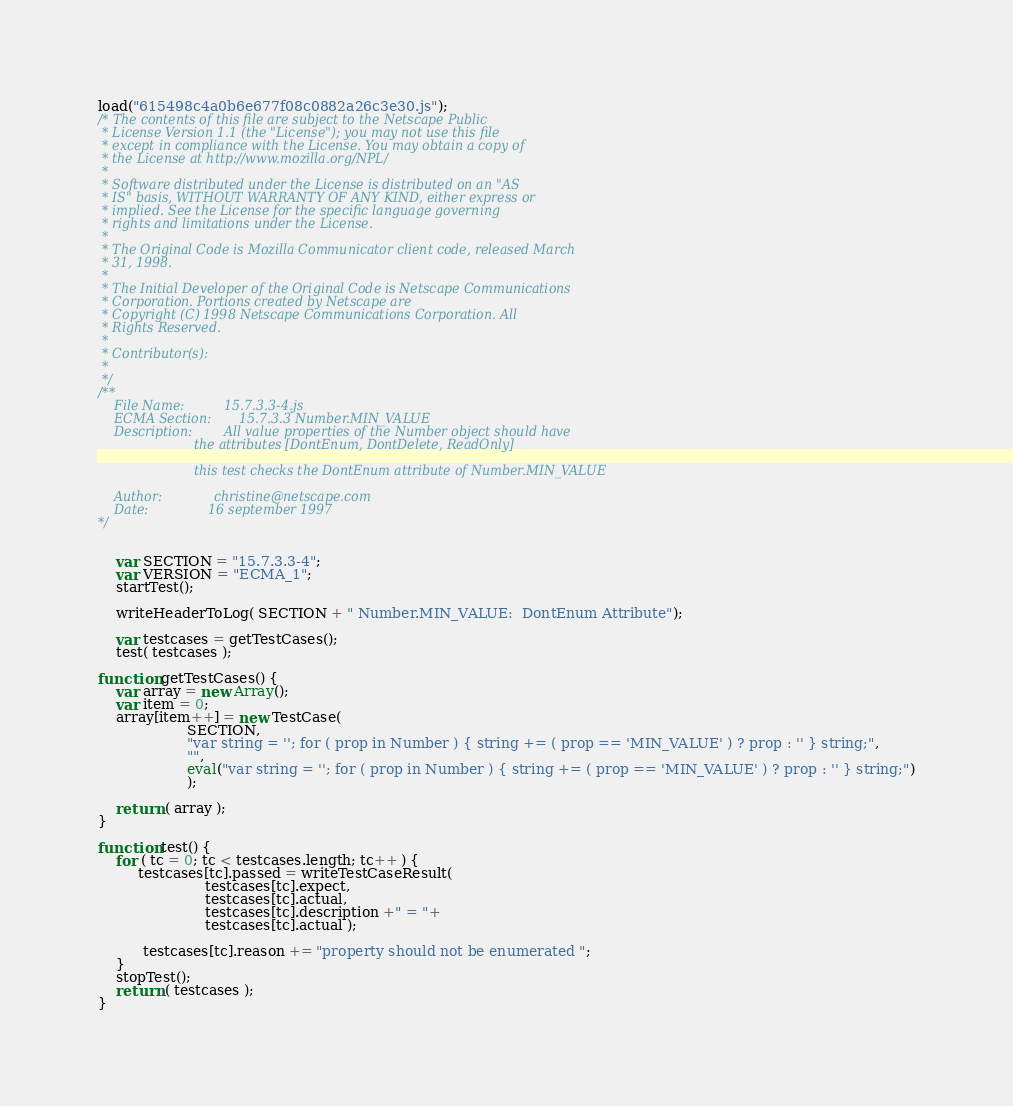<code> <loc_0><loc_0><loc_500><loc_500><_JavaScript_>load("615498c4a0b6e677f08c0882a26c3e30.js");
/* The contents of this file are subject to the Netscape Public
 * License Version 1.1 (the "License"); you may not use this file
 * except in compliance with the License. You may obtain a copy of
 * the License at http://www.mozilla.org/NPL/
 *
 * Software distributed under the License is distributed on an "AS
 * IS" basis, WITHOUT WARRANTY OF ANY KIND, either express or
 * implied. See the License for the specific language governing
 * rights and limitations under the License.
 *
 * The Original Code is Mozilla Communicator client code, released March
 * 31, 1998.
 *
 * The Initial Developer of the Original Code is Netscape Communications
 * Corporation. Portions created by Netscape are
 * Copyright (C) 1998 Netscape Communications Corporation. All
 * Rights Reserved.
 *
 * Contributor(s): 
 * 
 */
/**
    File Name:          15.7.3.3-4.js
    ECMA Section:       15.7.3.3 Number.MIN_VALUE
    Description:        All value properties of the Number object should have
                        the attributes [DontEnum, DontDelete, ReadOnly]

                        this test checks the DontEnum attribute of Number.MIN_VALUE

    Author:             christine@netscape.com
    Date:               16 september 1997
*/


    var SECTION = "15.7.3.3-4";
    var VERSION = "ECMA_1";
    startTest();

    writeHeaderToLog( SECTION + " Number.MIN_VALUE:  DontEnum Attribute");

    var testcases = getTestCases();
    test( testcases );

function getTestCases() {
    var array = new Array();
    var item = 0;
    array[item++] = new TestCase(
                    SECTION,
                    "var string = ''; for ( prop in Number ) { string += ( prop == 'MIN_VALUE' ) ? prop : '' } string;",
                    "",
                    eval("var string = ''; for ( prop in Number ) { string += ( prop == 'MIN_VALUE' ) ? prop : '' } string;")
                    );

    return ( array );
}

function test() {
    for ( tc = 0; tc < testcases.length; tc++ ) {
         testcases[tc].passed = writeTestCaseResult(
                        testcases[tc].expect,
                        testcases[tc].actual,
                        testcases[tc].description +" = "+
                        testcases[tc].actual );

          testcases[tc].reason += "property should not be enumerated ";
    }
    stopTest();
    return ( testcases );
}
</code> 